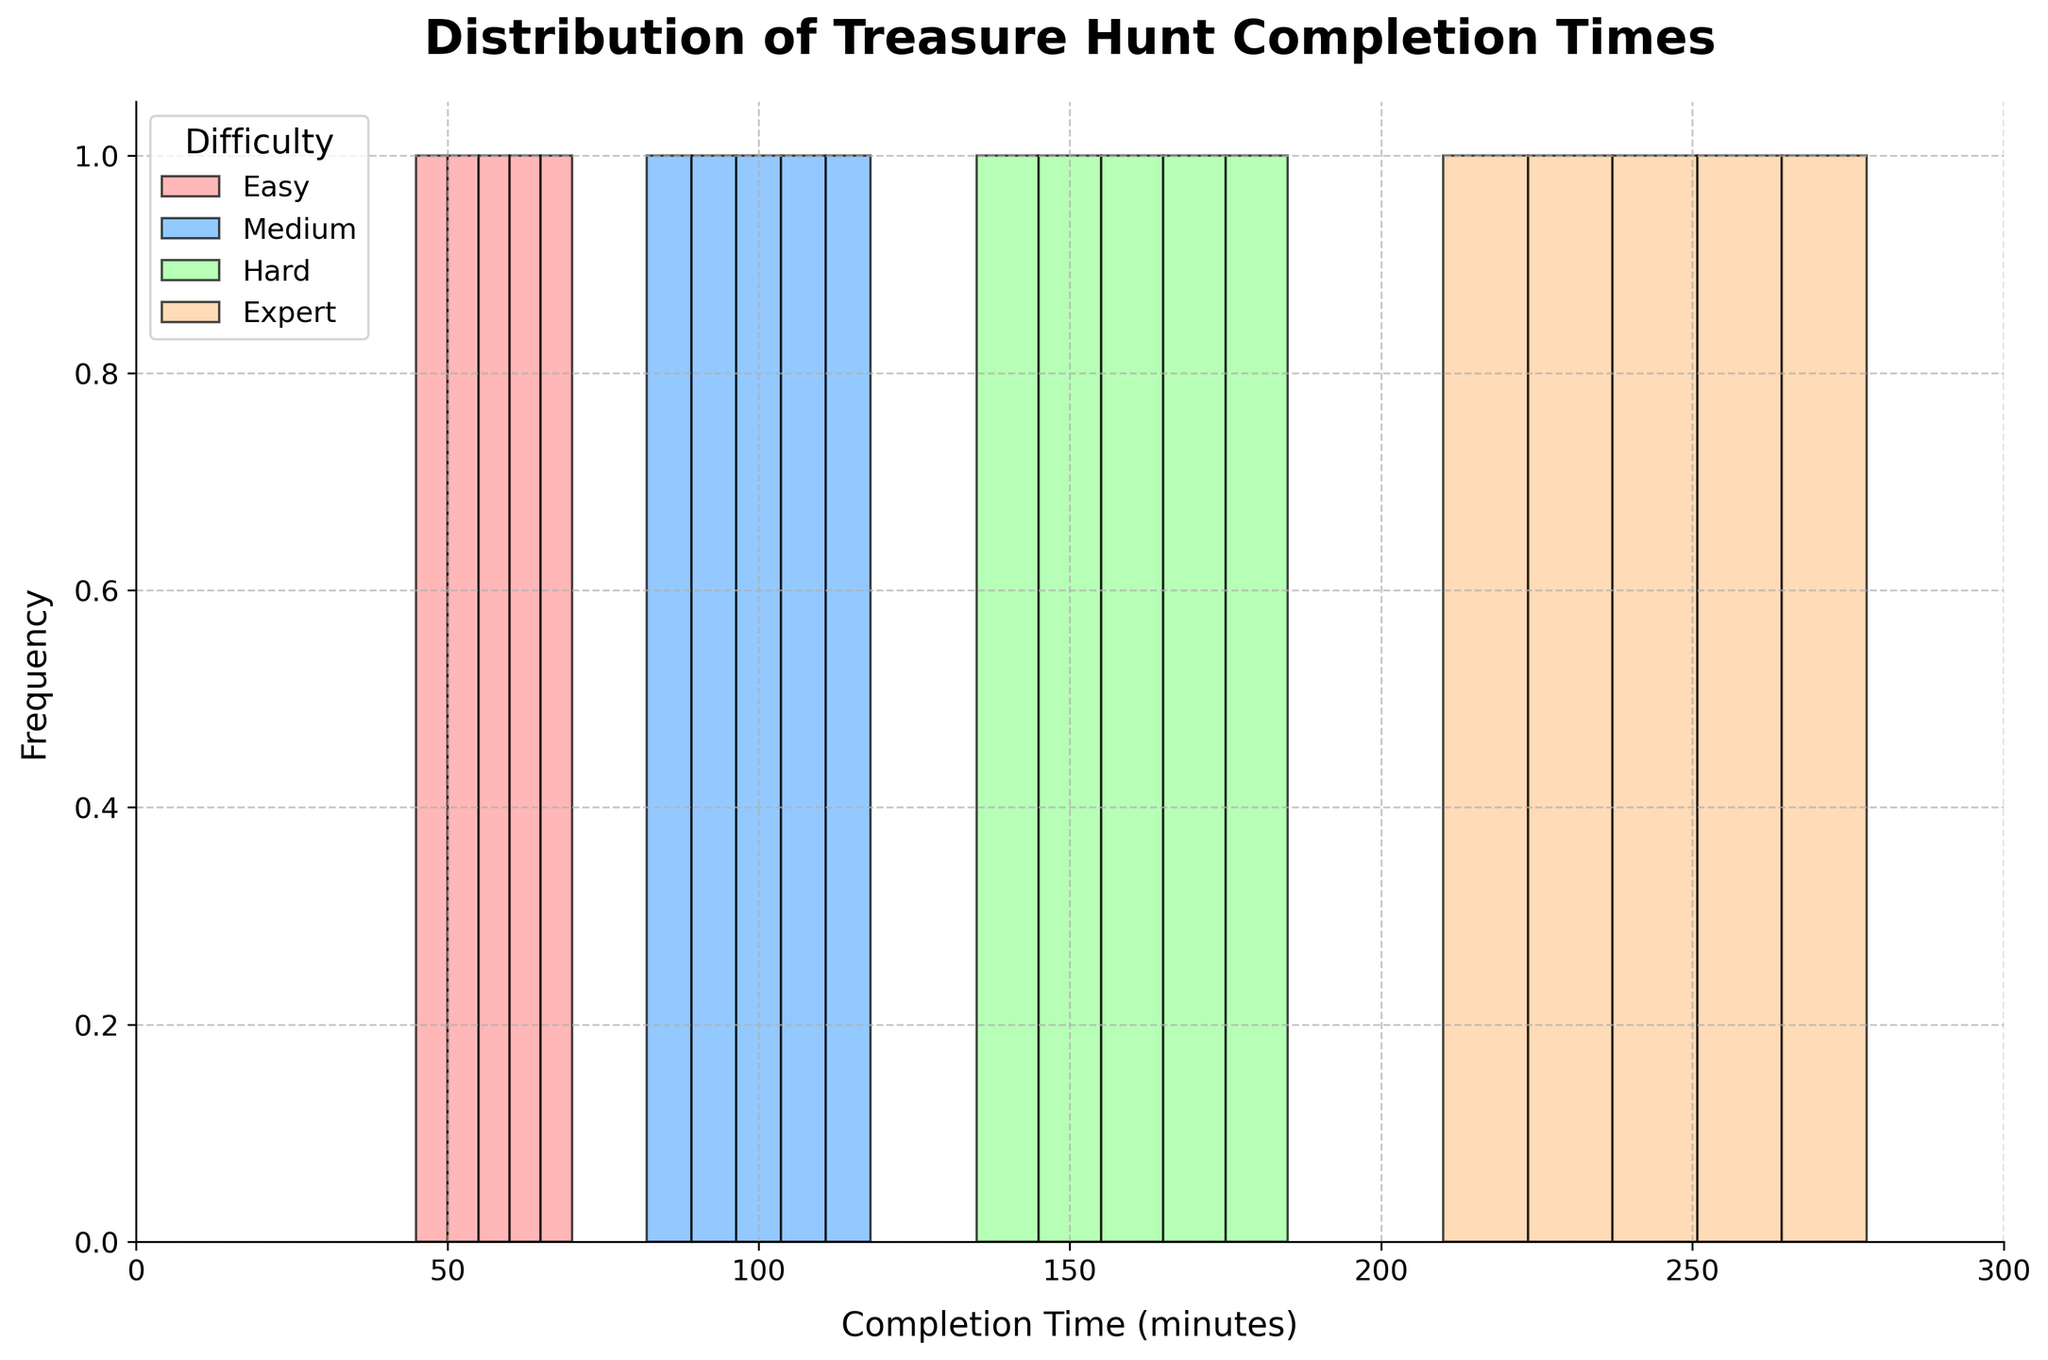What is the title of the plot? The title of the plot is displayed at the top of the figure in bold and large font.
Answer: Distribution of Treasure Hunt Completion Times What is the total number of difficulty levels shown in the figure? The plot legend lists all difficulty levels used in the histogram. By counting these, we get the answer.
Answer: 4 Which difficulty level shows the most spread-out completion times? By observing the width and spread of the histogram bars for each difficulty level, one can identify which has the widest spread.
Answer: Expert What is the range of completion times for the 'Easy' difficulty level? Look at the x-axis values corresponding to where the histogram bars for 'Easy' start and end.
Answer: 45 to 70 minutes How many completion times fall in the 100 to 150-minute range for the 'Medium' difficulty level? Check the histogram bins for 'Medium' that fall within the 100 to 150-minute range and count the number of bars in this range.
Answer: 3 What is the approximate median completion time for the 'Hard' difficulty level? Find the middle value in the ordered completion time data for 'Hard' difficulty level. Since there are five data points, the median is the third data point.
Answer: 160 minutes Compare the frequency of completion times between 'Easy' and 'Medium' difficulty levels for the 50-100 minute range. Examine the histogram bars for both 'Easy' and 'Medium' within the 50-100 minute range and compare their heights to determine frequency.
Answer: Easy has higher frequency What is the average completion time across all difficulty levels for the 200-300 minute range? Calculate the mean completion time for 'Expert' within the 200-300 minute range by adding up the times and dividing by the number of times.
Answer: 244.2 minutes Which difficulty level has the highest peak in their frequency distribution? Look at the tallest bar in the histogram for each difficulty level and compare them to identify the highest peak.
Answer: Easy What is the proportion of completion times that fall below 100 minutes for the 'Medium' difficulty level? Identify the total number of completion times for 'Medium' and count how many fall below 100 minutes, then divide the two quantities.
Answer: 2 out of 5 